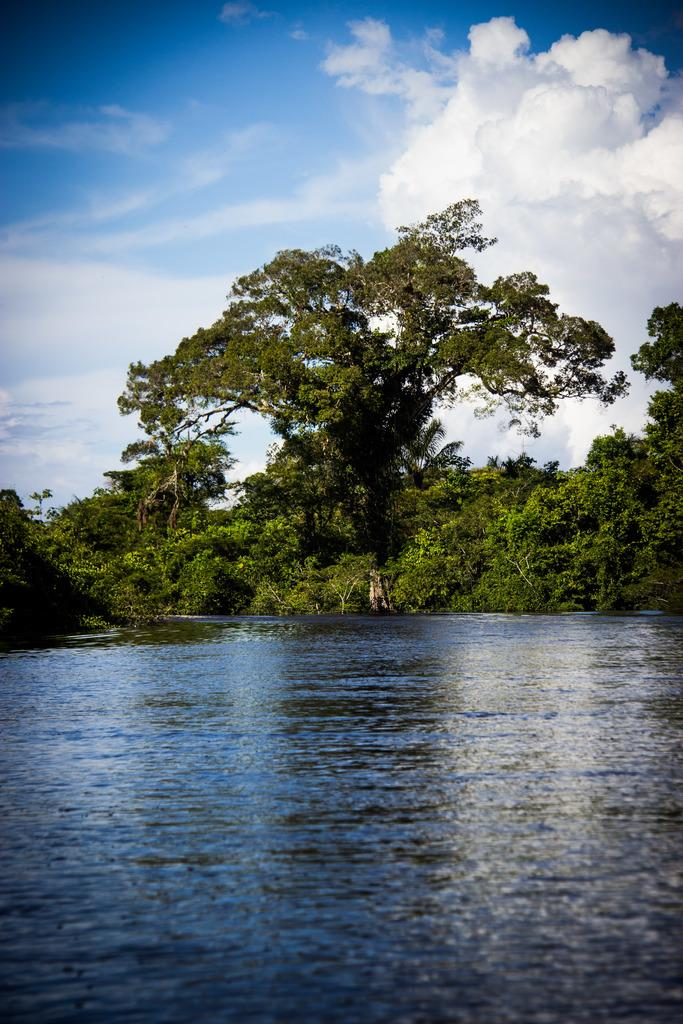What is present in the front of the image? There is water in the front of the image. What can be seen in the background of the image? There are trees and clouds visible in the background of the image. What else is visible in the background of the image? The sky is visible in the background of the image. How many babies are playing with a glove in the image? There are no babies or gloves present in the image. What type of pig can be seen in the image? There is no pig present in the image. 